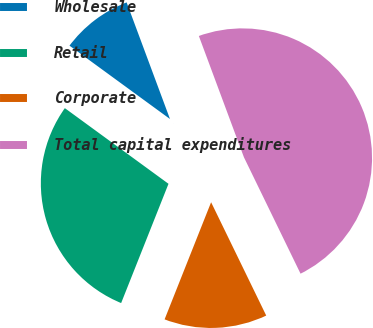Convert chart. <chart><loc_0><loc_0><loc_500><loc_500><pie_chart><fcel>Wholesale<fcel>Retail<fcel>Corporate<fcel>Total capital expenditures<nl><fcel>9.3%<fcel>29.02%<fcel>13.22%<fcel>48.46%<nl></chart> 